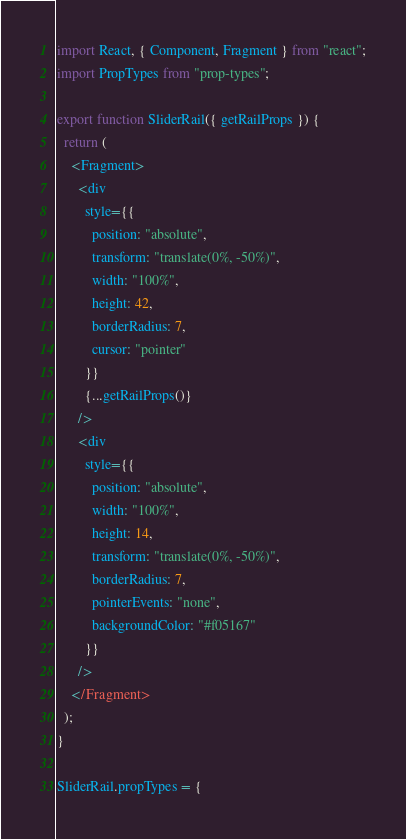<code> <loc_0><loc_0><loc_500><loc_500><_JavaScript_>import React, { Component, Fragment } from "react";
import PropTypes from "prop-types";

export function SliderRail({ getRailProps }) {
  return (
    <Fragment>
      <div
        style={{
          position: "absolute",
          transform: "translate(0%, -50%)",
          width: "100%",
          height: 42,
          borderRadius: 7,
          cursor: "pointer"
        }}
        {...getRailProps()}
      />
      <div
        style={{
          position: "absolute",
          width: "100%",
          height: 14,
          transform: "translate(0%, -50%)",
          borderRadius: 7,
          pointerEvents: "none",
          backgroundColor: "#f05167"
        }}
      />
    </Fragment>
  );
}

SliderRail.propTypes = {</code> 